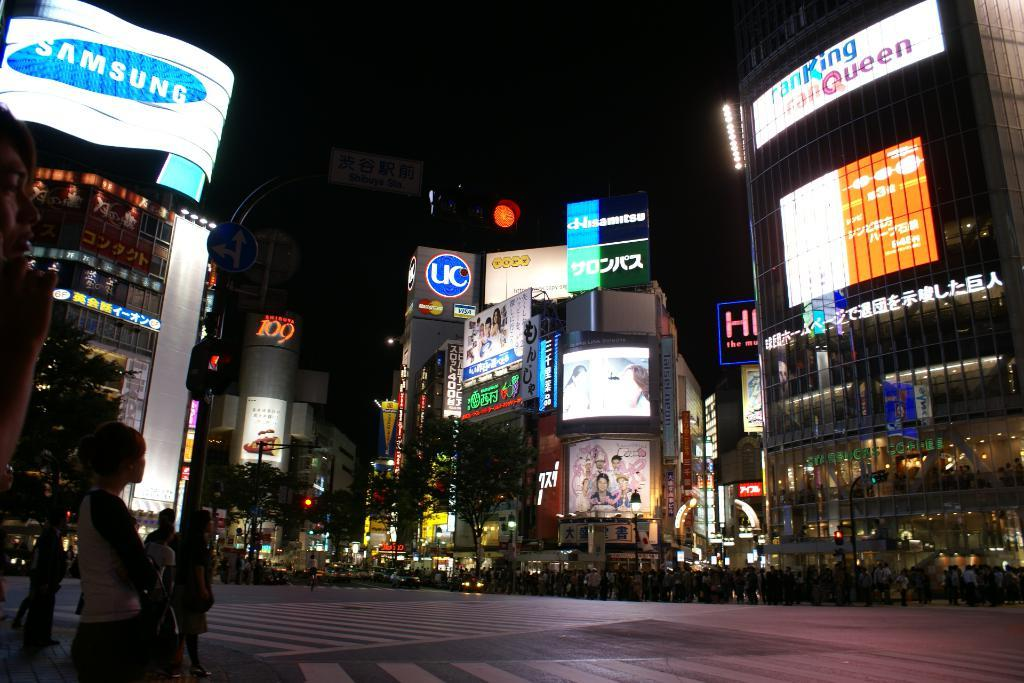What is the main feature of the image? There is a road in the image. What are the people on the road doing? There are people standing on the road. What can be seen in the background of the image? There are buildings, traffic signals, trees, and wordings visible in the background of the image. How many knees are visible in the image? There is no specific mention of knees in the image, so it is not possible to determine the number of knees visible. 